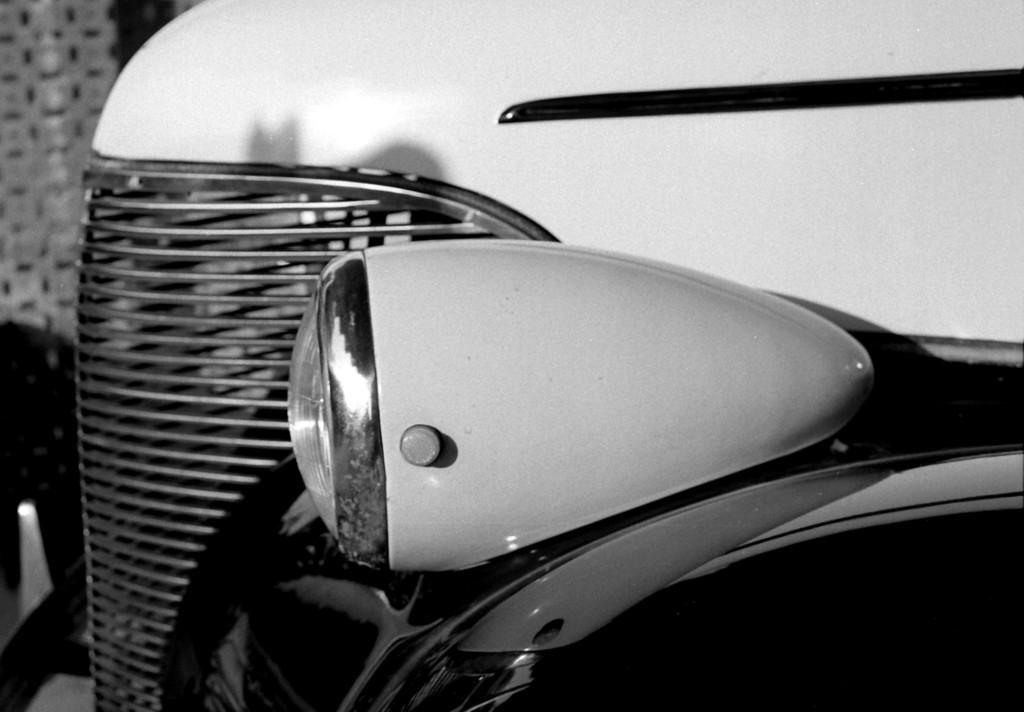Describe this image in one or two sentences. In this picture we can see a vehicle and it is a black and white photography. 